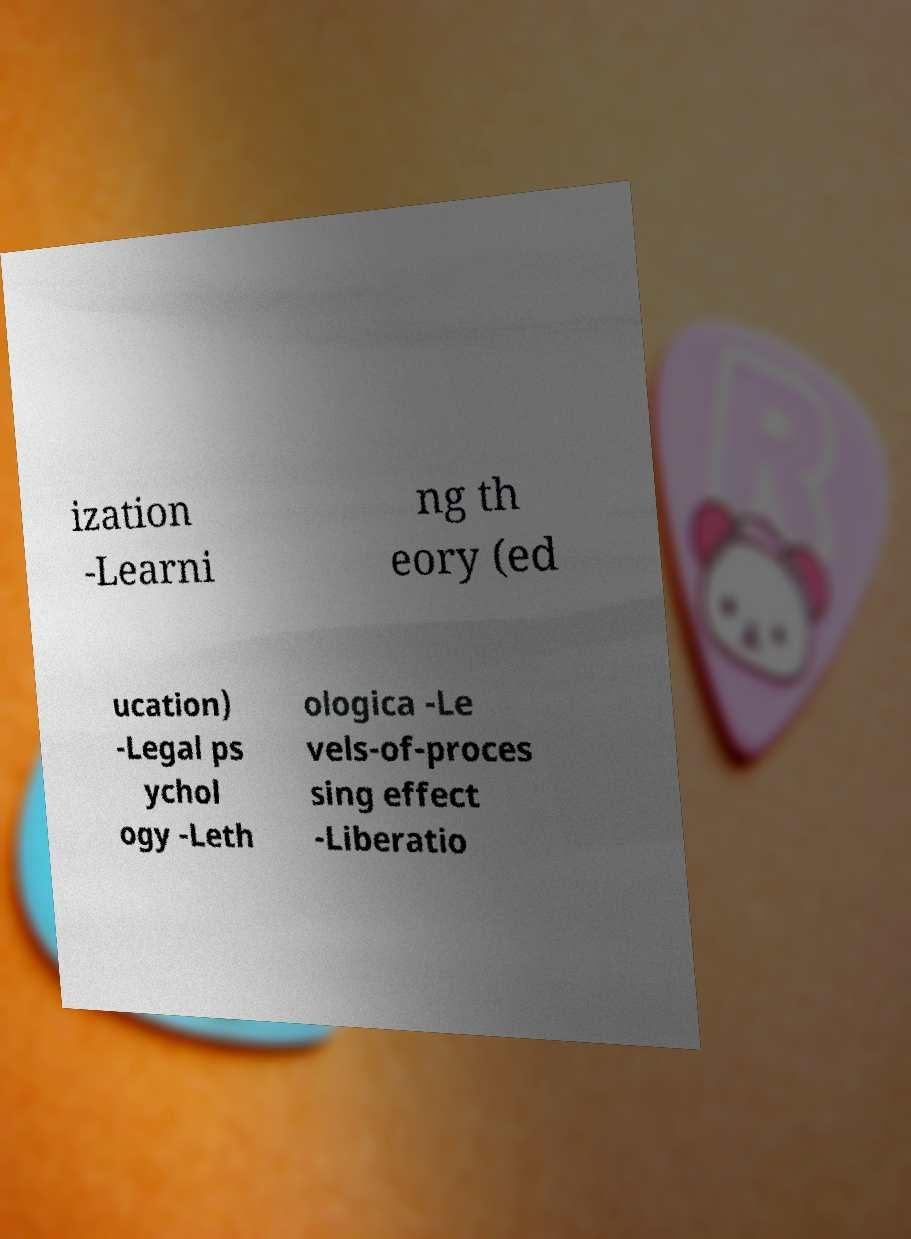I need the written content from this picture converted into text. Can you do that? ization -Learni ng th eory (ed ucation) -Legal ps ychol ogy -Leth ologica -Le vels-of-proces sing effect -Liberatio 